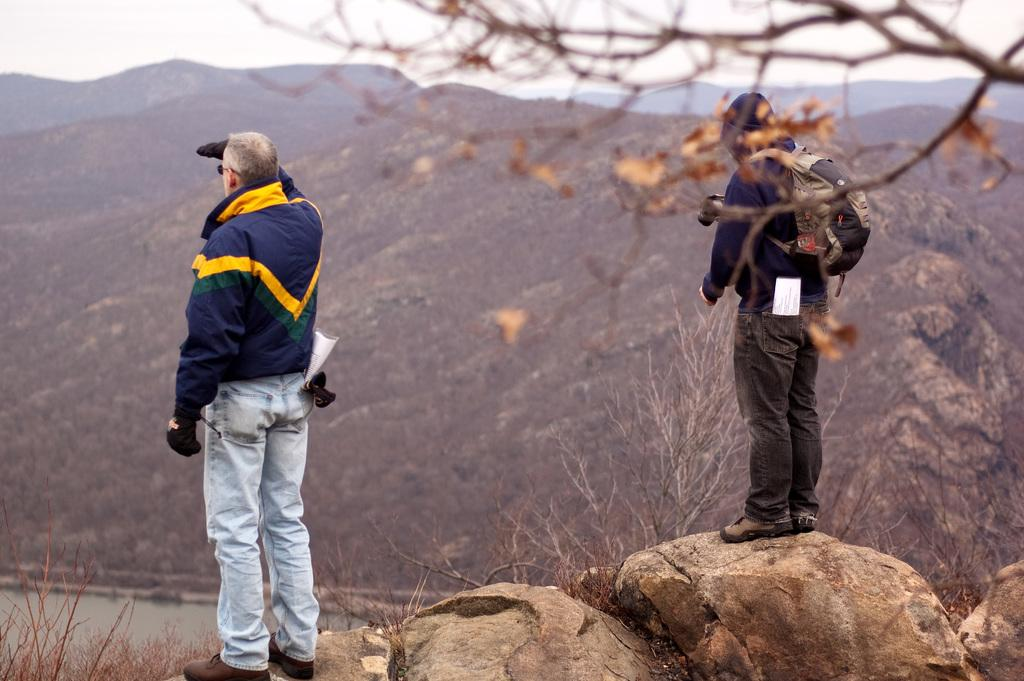How many people are in the image? There are two persons standing on rocks in the image. What can be seen in the background of the image? There are mountains, trees, and the sky visible in the background of the image. Where is the faucet located in the image? There is no faucet present in the image. What type of animals can be seen grazing in the background of the image? There are no animals visible in the image; only mountains, trees, and the sky can be seen in the background. 